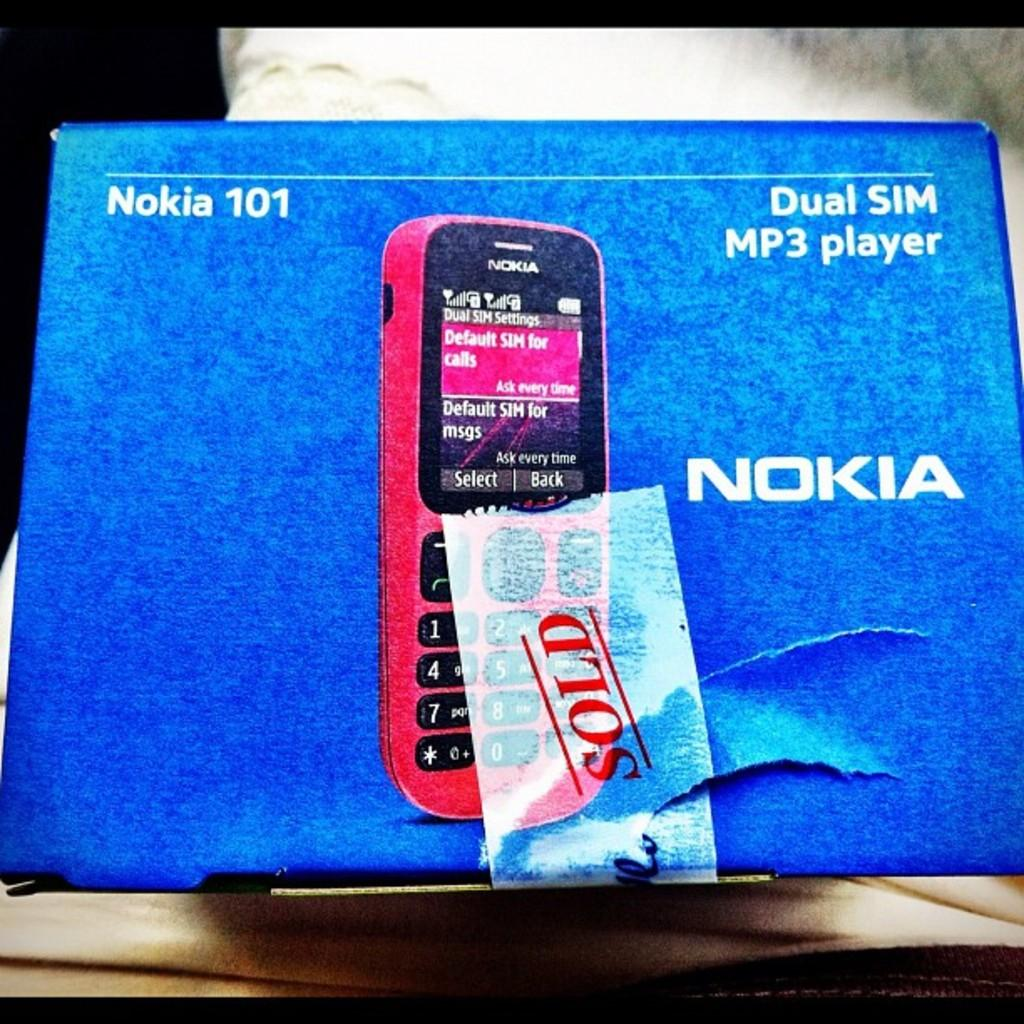<image>
Relay a brief, clear account of the picture shown. a phone that has a Nokia on it 